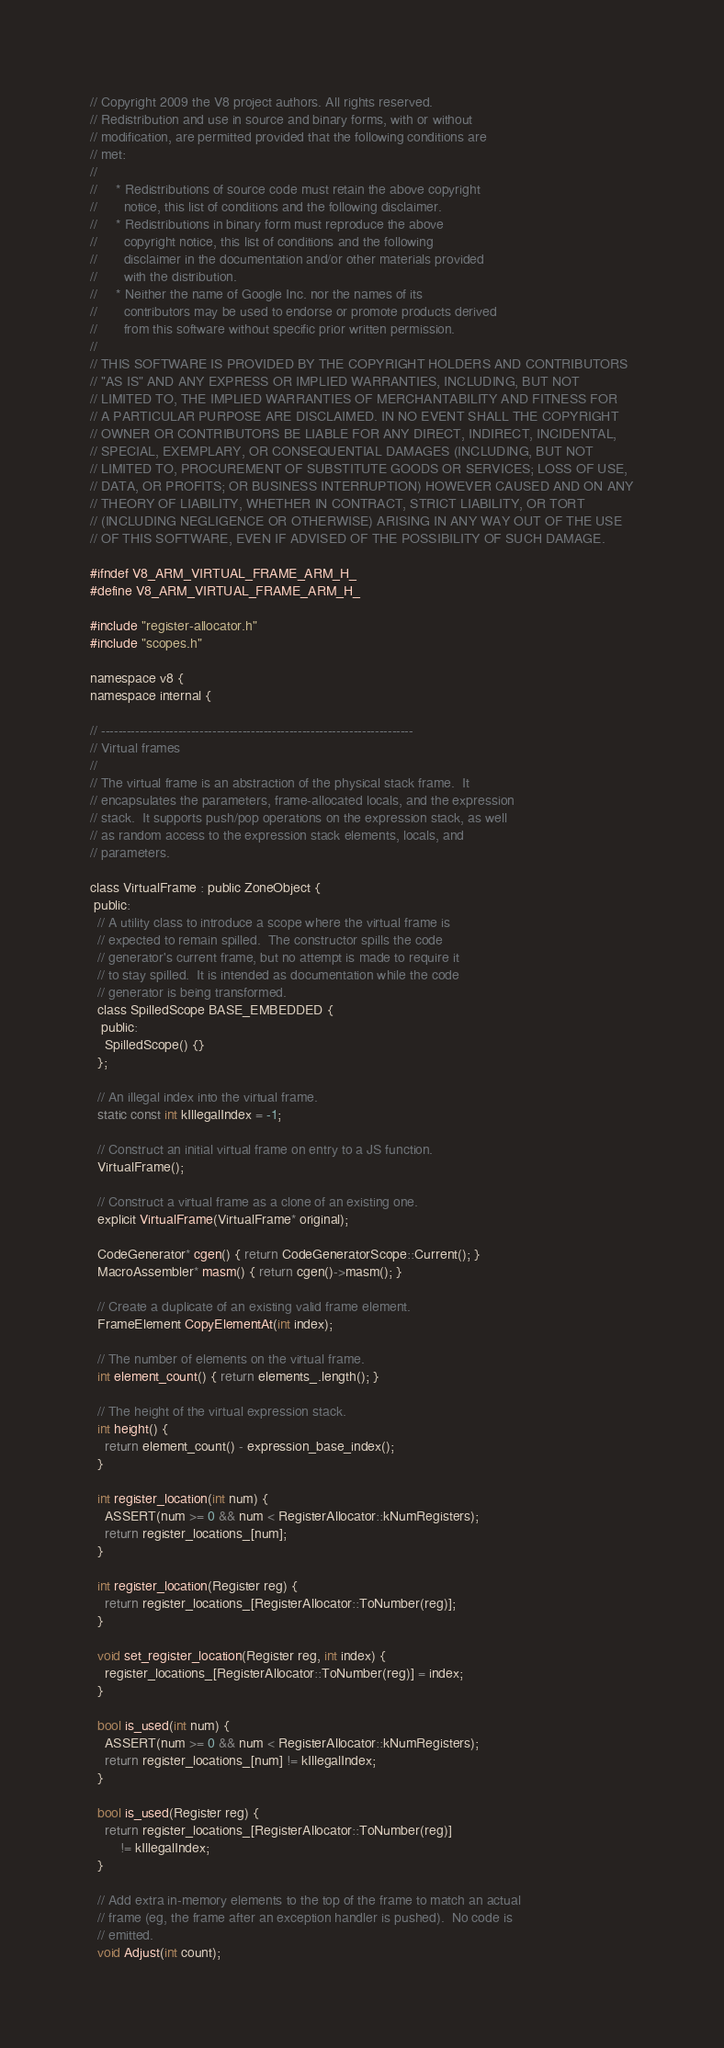<code> <loc_0><loc_0><loc_500><loc_500><_C_>// Copyright 2009 the V8 project authors. All rights reserved.
// Redistribution and use in source and binary forms, with or without
// modification, are permitted provided that the following conditions are
// met:
//
//     * Redistributions of source code must retain the above copyright
//       notice, this list of conditions and the following disclaimer.
//     * Redistributions in binary form must reproduce the above
//       copyright notice, this list of conditions and the following
//       disclaimer in the documentation and/or other materials provided
//       with the distribution.
//     * Neither the name of Google Inc. nor the names of its
//       contributors may be used to endorse or promote products derived
//       from this software without specific prior written permission.
//
// THIS SOFTWARE IS PROVIDED BY THE COPYRIGHT HOLDERS AND CONTRIBUTORS
// "AS IS" AND ANY EXPRESS OR IMPLIED WARRANTIES, INCLUDING, BUT NOT
// LIMITED TO, THE IMPLIED WARRANTIES OF MERCHANTABILITY AND FITNESS FOR
// A PARTICULAR PURPOSE ARE DISCLAIMED. IN NO EVENT SHALL THE COPYRIGHT
// OWNER OR CONTRIBUTORS BE LIABLE FOR ANY DIRECT, INDIRECT, INCIDENTAL,
// SPECIAL, EXEMPLARY, OR CONSEQUENTIAL DAMAGES (INCLUDING, BUT NOT
// LIMITED TO, PROCUREMENT OF SUBSTITUTE GOODS OR SERVICES; LOSS OF USE,
// DATA, OR PROFITS; OR BUSINESS INTERRUPTION) HOWEVER CAUSED AND ON ANY
// THEORY OF LIABILITY, WHETHER IN CONTRACT, STRICT LIABILITY, OR TORT
// (INCLUDING NEGLIGENCE OR OTHERWISE) ARISING IN ANY WAY OUT OF THE USE
// OF THIS SOFTWARE, EVEN IF ADVISED OF THE POSSIBILITY OF SUCH DAMAGE.

#ifndef V8_ARM_VIRTUAL_FRAME_ARM_H_
#define V8_ARM_VIRTUAL_FRAME_ARM_H_

#include "register-allocator.h"
#include "scopes.h"

namespace v8 {
namespace internal {

// -------------------------------------------------------------------------
// Virtual frames
//
// The virtual frame is an abstraction of the physical stack frame.  It
// encapsulates the parameters, frame-allocated locals, and the expression
// stack.  It supports push/pop operations on the expression stack, as well
// as random access to the expression stack elements, locals, and
// parameters.

class VirtualFrame : public ZoneObject {
 public:
  // A utility class to introduce a scope where the virtual frame is
  // expected to remain spilled.  The constructor spills the code
  // generator's current frame, but no attempt is made to require it
  // to stay spilled.  It is intended as documentation while the code
  // generator is being transformed.
  class SpilledScope BASE_EMBEDDED {
   public:
    SpilledScope() {}
  };

  // An illegal index into the virtual frame.
  static const int kIllegalIndex = -1;

  // Construct an initial virtual frame on entry to a JS function.
  VirtualFrame();

  // Construct a virtual frame as a clone of an existing one.
  explicit VirtualFrame(VirtualFrame* original);

  CodeGenerator* cgen() { return CodeGeneratorScope::Current(); }
  MacroAssembler* masm() { return cgen()->masm(); }

  // Create a duplicate of an existing valid frame element.
  FrameElement CopyElementAt(int index);

  // The number of elements on the virtual frame.
  int element_count() { return elements_.length(); }

  // The height of the virtual expression stack.
  int height() {
    return element_count() - expression_base_index();
  }

  int register_location(int num) {
    ASSERT(num >= 0 && num < RegisterAllocator::kNumRegisters);
    return register_locations_[num];
  }

  int register_location(Register reg) {
    return register_locations_[RegisterAllocator::ToNumber(reg)];
  }

  void set_register_location(Register reg, int index) {
    register_locations_[RegisterAllocator::ToNumber(reg)] = index;
  }

  bool is_used(int num) {
    ASSERT(num >= 0 && num < RegisterAllocator::kNumRegisters);
    return register_locations_[num] != kIllegalIndex;
  }

  bool is_used(Register reg) {
    return register_locations_[RegisterAllocator::ToNumber(reg)]
        != kIllegalIndex;
  }

  // Add extra in-memory elements to the top of the frame to match an actual
  // frame (eg, the frame after an exception handler is pushed).  No code is
  // emitted.
  void Adjust(int count);
</code> 